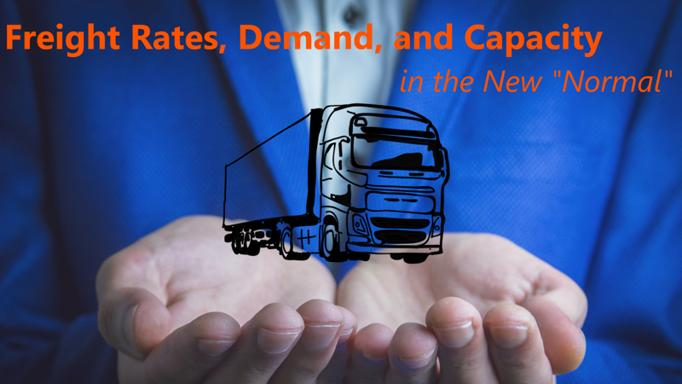How do changes in global economic conditions influence freight rates? Changes in global economic conditions directly influence freight rates through factors like fuel costs, tariffs, and international trade volumes. Economic downturns or growth in key markets can lead to decreased or increased need for transportation services, subsequently driving the rates up or down depending on the demand-supply balance. 